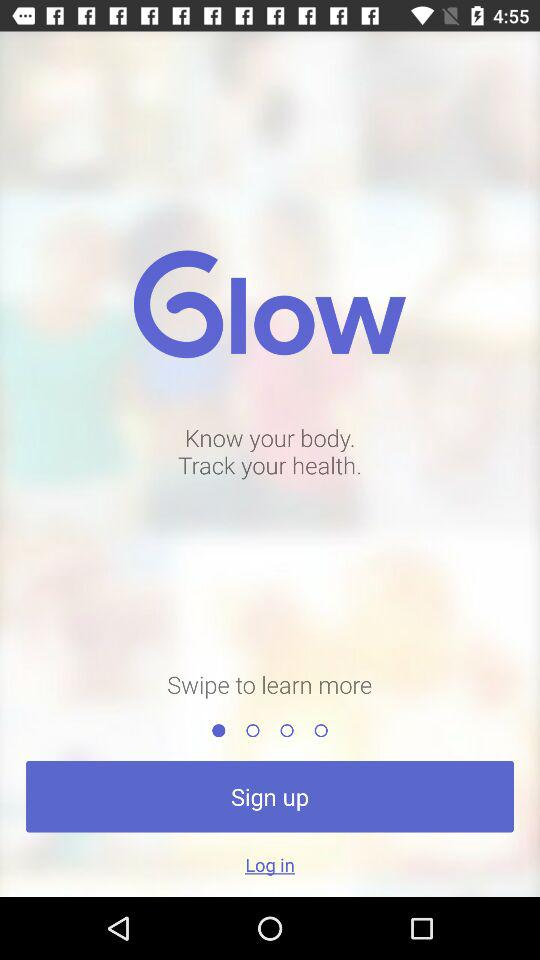What is the app name? The app name is "Glow". 